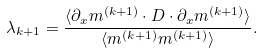Convert formula to latex. <formula><loc_0><loc_0><loc_500><loc_500>\lambda _ { k + 1 } = \frac { \langle \partial _ { x } m ^ { ( k + 1 ) } \cdot D \cdot \partial _ { x } m ^ { ( k + 1 ) } \rangle } { \langle m ^ { ( k + 1 ) } m ^ { ( k + 1 ) } \rangle } .</formula> 